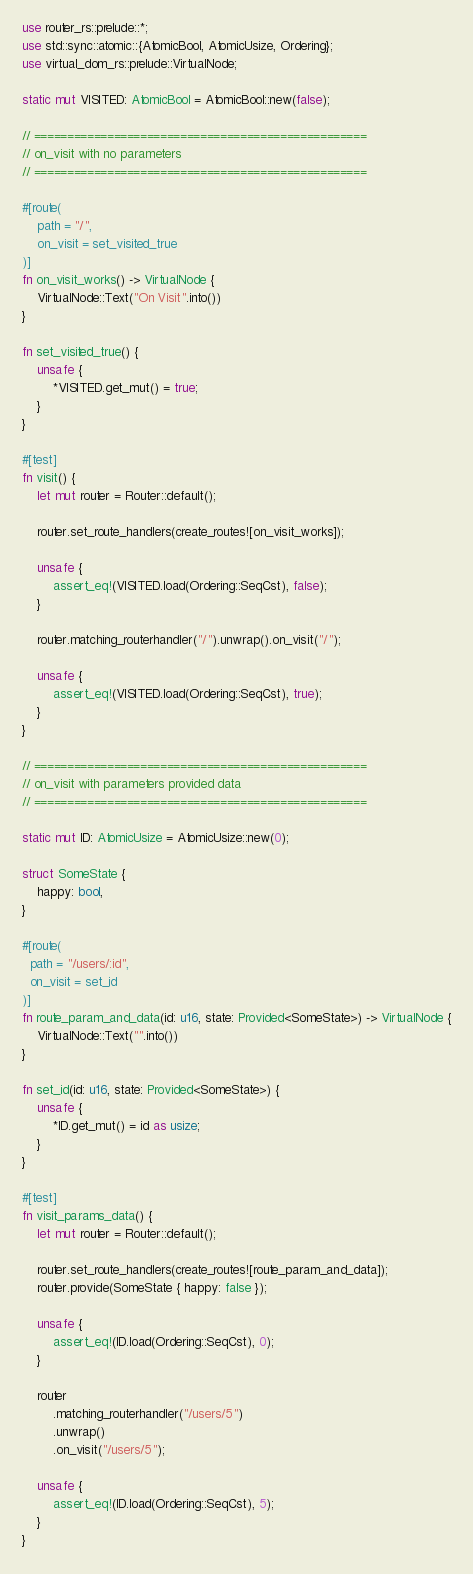Convert code to text. <code><loc_0><loc_0><loc_500><loc_500><_Rust_>use router_rs::prelude::*;
use std::sync::atomic::{AtomicBool, AtomicUsize, Ordering};
use virtual_dom_rs::prelude::VirtualNode;

static mut VISITED: AtomicBool = AtomicBool::new(false);

// ==================================================
// on_visit with no parameters
// ==================================================

#[route(
    path = "/",
    on_visit = set_visited_true
)]
fn on_visit_works() -> VirtualNode {
    VirtualNode::Text("On Visit".into())
}

fn set_visited_true() {
    unsafe {
        *VISITED.get_mut() = true;
    }
}

#[test]
fn visit() {
    let mut router = Router::default();

    router.set_route_handlers(create_routes![on_visit_works]);

    unsafe {
        assert_eq!(VISITED.load(Ordering::SeqCst), false);
    }

    router.matching_routerhandler("/").unwrap().on_visit("/");

    unsafe {
        assert_eq!(VISITED.load(Ordering::SeqCst), true);
    }
}

// ==================================================
// on_visit with parameters provided data
// ==================================================

static mut ID: AtomicUsize = AtomicUsize::new(0);

struct SomeState {
    happy: bool,
}

#[route(
  path = "/users/:id",
  on_visit = set_id
)]
fn route_param_and_data(id: u16, state: Provided<SomeState>) -> VirtualNode {
    VirtualNode::Text("".into())
}

fn set_id(id: u16, state: Provided<SomeState>) {
    unsafe {
        *ID.get_mut() = id as usize;
    }
}

#[test]
fn visit_params_data() {
    let mut router = Router::default();

    router.set_route_handlers(create_routes![route_param_and_data]);
    router.provide(SomeState { happy: false });

    unsafe {
        assert_eq!(ID.load(Ordering::SeqCst), 0);
    }

    router
        .matching_routerhandler("/users/5")
        .unwrap()
        .on_visit("/users/5");

    unsafe {
        assert_eq!(ID.load(Ordering::SeqCst), 5);
    }
}
</code> 